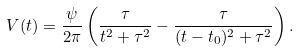Convert formula to latex. <formula><loc_0><loc_0><loc_500><loc_500>V ( t ) = \frac { \psi } { 2 \pi } \left ( \frac { \tau } { t ^ { 2 } + \tau ^ { 2 } } - \frac { \tau } { ( t - t _ { 0 } ) ^ { 2 } + \tau ^ { 2 } } \right ) .</formula> 